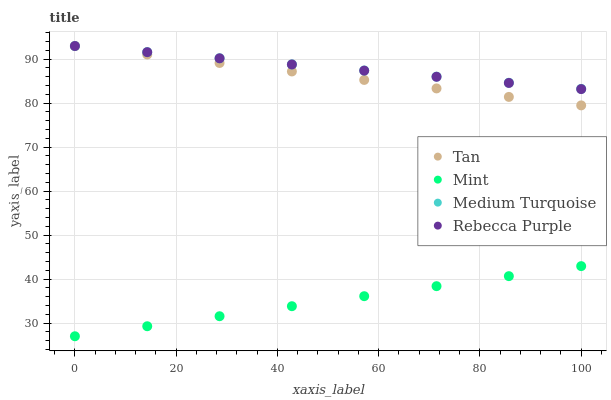Does Mint have the minimum area under the curve?
Answer yes or no. Yes. Does Medium Turquoise have the maximum area under the curve?
Answer yes or no. Yes. Does Rebecca Purple have the minimum area under the curve?
Answer yes or no. No. Does Rebecca Purple have the maximum area under the curve?
Answer yes or no. No. Is Rebecca Purple the smoothest?
Answer yes or no. Yes. Is Medium Turquoise the roughest?
Answer yes or no. Yes. Is Mint the smoothest?
Answer yes or no. No. Is Mint the roughest?
Answer yes or no. No. Does Mint have the lowest value?
Answer yes or no. Yes. Does Rebecca Purple have the lowest value?
Answer yes or no. No. Does Medium Turquoise have the highest value?
Answer yes or no. Yes. Does Mint have the highest value?
Answer yes or no. No. Is Mint less than Rebecca Purple?
Answer yes or no. Yes. Is Rebecca Purple greater than Mint?
Answer yes or no. Yes. Does Rebecca Purple intersect Medium Turquoise?
Answer yes or no. Yes. Is Rebecca Purple less than Medium Turquoise?
Answer yes or no. No. Is Rebecca Purple greater than Medium Turquoise?
Answer yes or no. No. Does Mint intersect Rebecca Purple?
Answer yes or no. No. 